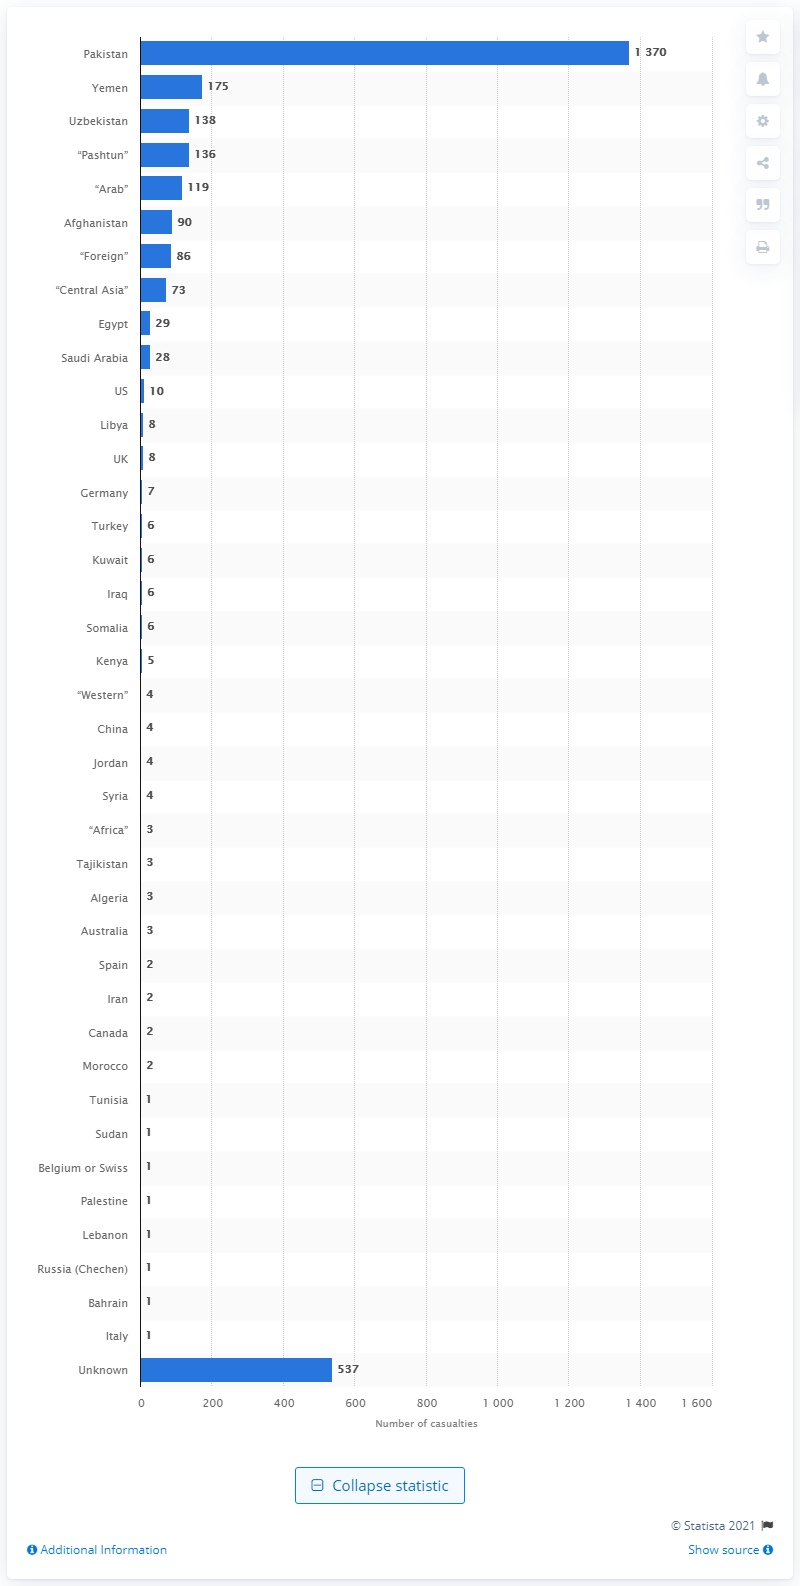Point out several critical features in this image. According to information available, 175 Yemeni nationals were killed in U.S. drone strikes. 